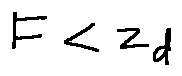Convert formula to latex. <formula><loc_0><loc_0><loc_500><loc_500>F < z _ { d }</formula> 